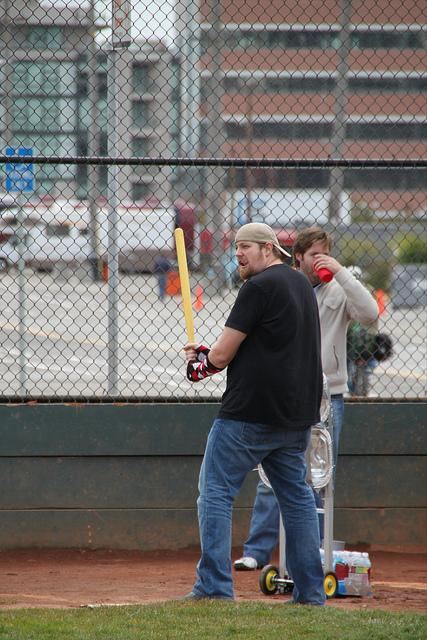What is the man in the black ready to do? hit ball 